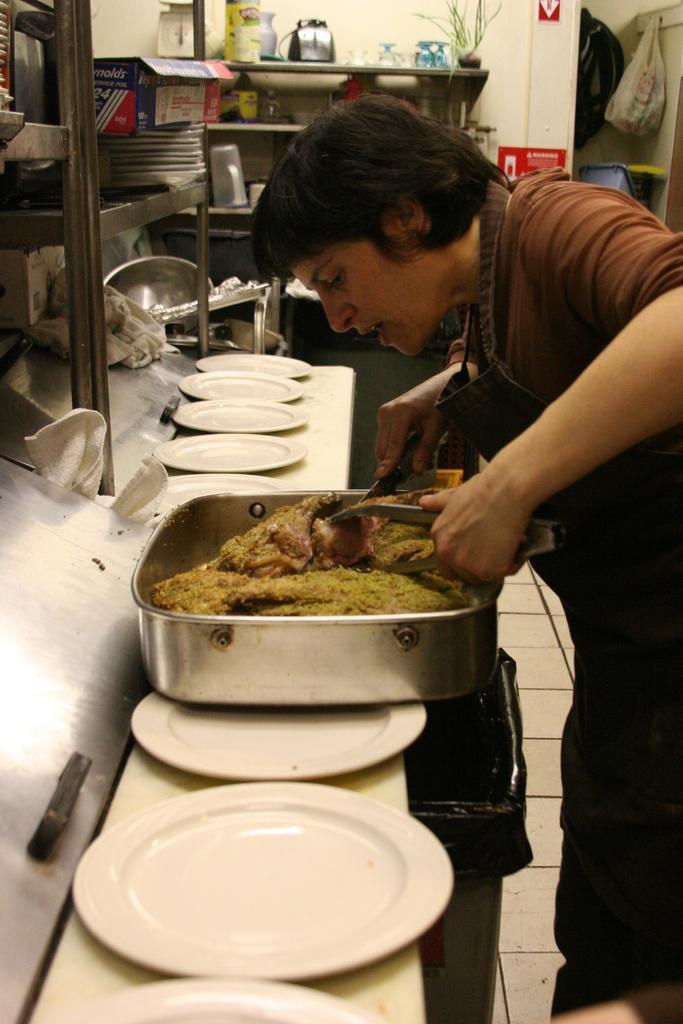Can you describe this image briefly? In this image there is a woman standing towards the right of the image, she is holding an object, there is a bowl, there is food in the bowl, there are plates on the object, there are objects towards the right of the image, there are shelves, there are objects in the shelves, there is a bag, there is a wall towards the top of the image, there are objects on the wall, there is floor towards the bottom of the image. 